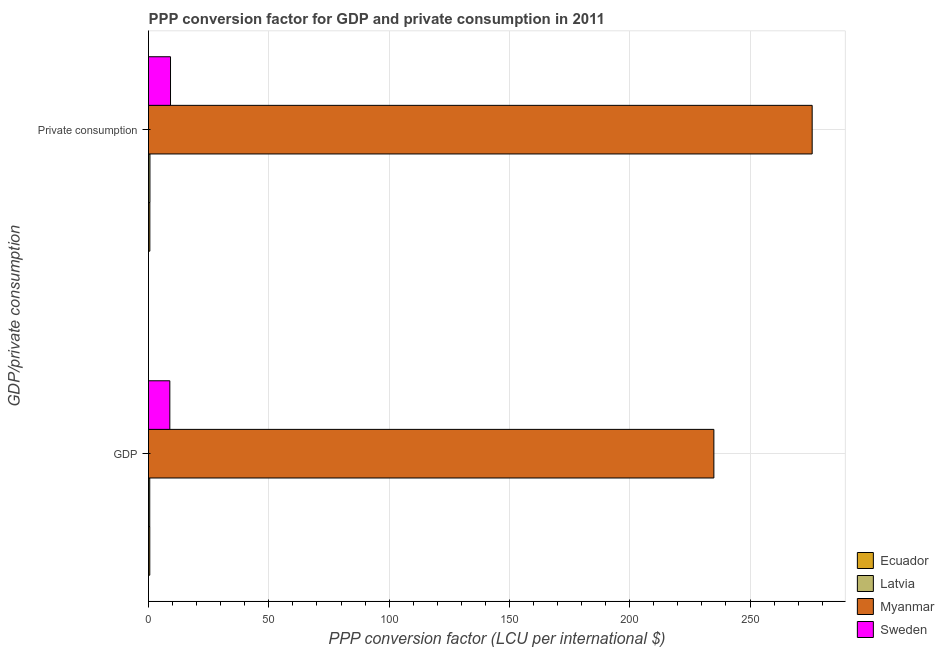How many different coloured bars are there?
Ensure brevity in your answer.  4. Are the number of bars on each tick of the Y-axis equal?
Provide a short and direct response. Yes. What is the label of the 1st group of bars from the top?
Ensure brevity in your answer.   Private consumption. What is the ppp conversion factor for private consumption in Myanmar?
Offer a terse response. 275.83. Across all countries, what is the maximum ppp conversion factor for gdp?
Your answer should be very brief. 234.97. Across all countries, what is the minimum ppp conversion factor for gdp?
Offer a terse response. 0.51. In which country was the ppp conversion factor for private consumption maximum?
Your answer should be compact. Myanmar. In which country was the ppp conversion factor for private consumption minimum?
Your answer should be compact. Ecuador. What is the total ppp conversion factor for private consumption in the graph?
Offer a terse response. 286.1. What is the difference between the ppp conversion factor for gdp in Sweden and that in Myanmar?
Offer a terse response. -226.12. What is the difference between the ppp conversion factor for private consumption in Sweden and the ppp conversion factor for gdp in Latvia?
Keep it short and to the point. 8.63. What is the average ppp conversion factor for gdp per country?
Your response must be concise. 61.21. What is the difference between the ppp conversion factor for private consumption and ppp conversion factor for gdp in Ecuador?
Your answer should be very brief. 0.02. What is the ratio of the ppp conversion factor for private consumption in Latvia to that in Myanmar?
Keep it short and to the point. 0. Is the ppp conversion factor for gdp in Sweden less than that in Latvia?
Provide a succinct answer. No. In how many countries, is the ppp conversion factor for gdp greater than the average ppp conversion factor for gdp taken over all countries?
Ensure brevity in your answer.  1. What does the 4th bar from the top in  Private consumption represents?
Your answer should be compact. Ecuador. What does the 4th bar from the bottom in  Private consumption represents?
Make the answer very short. Sweden. How many bars are there?
Provide a succinct answer. 8. Are all the bars in the graph horizontal?
Provide a succinct answer. Yes. Does the graph contain any zero values?
Keep it short and to the point. No. Where does the legend appear in the graph?
Make the answer very short. Bottom right. What is the title of the graph?
Your response must be concise. PPP conversion factor for GDP and private consumption in 2011. Does "Germany" appear as one of the legend labels in the graph?
Your answer should be very brief. No. What is the label or title of the X-axis?
Your answer should be compact. PPP conversion factor (LCU per international $). What is the label or title of the Y-axis?
Offer a terse response. GDP/private consumption. What is the PPP conversion factor (LCU per international $) of Ecuador in GDP?
Offer a terse response. 0.53. What is the PPP conversion factor (LCU per international $) of Latvia in GDP?
Your answer should be very brief. 0.51. What is the PPP conversion factor (LCU per international $) of Myanmar in GDP?
Your answer should be very brief. 234.97. What is the PPP conversion factor (LCU per international $) in Sweden in GDP?
Keep it short and to the point. 8.85. What is the PPP conversion factor (LCU per international $) in Ecuador in  Private consumption?
Give a very brief answer. 0.55. What is the PPP conversion factor (LCU per international $) of Latvia in  Private consumption?
Provide a short and direct response. 0.59. What is the PPP conversion factor (LCU per international $) in Myanmar in  Private consumption?
Offer a terse response. 275.83. What is the PPP conversion factor (LCU per international $) of Sweden in  Private consumption?
Offer a very short reply. 9.14. Across all GDP/private consumption, what is the maximum PPP conversion factor (LCU per international $) in Ecuador?
Offer a terse response. 0.55. Across all GDP/private consumption, what is the maximum PPP conversion factor (LCU per international $) in Latvia?
Your response must be concise. 0.59. Across all GDP/private consumption, what is the maximum PPP conversion factor (LCU per international $) of Myanmar?
Provide a succinct answer. 275.83. Across all GDP/private consumption, what is the maximum PPP conversion factor (LCU per international $) of Sweden?
Keep it short and to the point. 9.14. Across all GDP/private consumption, what is the minimum PPP conversion factor (LCU per international $) of Ecuador?
Your response must be concise. 0.53. Across all GDP/private consumption, what is the minimum PPP conversion factor (LCU per international $) of Latvia?
Offer a terse response. 0.51. Across all GDP/private consumption, what is the minimum PPP conversion factor (LCU per international $) in Myanmar?
Provide a short and direct response. 234.97. Across all GDP/private consumption, what is the minimum PPP conversion factor (LCU per international $) in Sweden?
Your response must be concise. 8.85. What is the total PPP conversion factor (LCU per international $) in Ecuador in the graph?
Make the answer very short. 1.07. What is the total PPP conversion factor (LCU per international $) of Latvia in the graph?
Make the answer very short. 1.09. What is the total PPP conversion factor (LCU per international $) in Myanmar in the graph?
Your answer should be compact. 510.8. What is the total PPP conversion factor (LCU per international $) of Sweden in the graph?
Give a very brief answer. 17.99. What is the difference between the PPP conversion factor (LCU per international $) of Ecuador in GDP and that in  Private consumption?
Your response must be concise. -0.02. What is the difference between the PPP conversion factor (LCU per international $) in Latvia in GDP and that in  Private consumption?
Keep it short and to the point. -0.08. What is the difference between the PPP conversion factor (LCU per international $) of Myanmar in GDP and that in  Private consumption?
Provide a succinct answer. -40.85. What is the difference between the PPP conversion factor (LCU per international $) in Sweden in GDP and that in  Private consumption?
Provide a short and direct response. -0.29. What is the difference between the PPP conversion factor (LCU per international $) in Ecuador in GDP and the PPP conversion factor (LCU per international $) in Latvia in  Private consumption?
Offer a very short reply. -0.06. What is the difference between the PPP conversion factor (LCU per international $) of Ecuador in GDP and the PPP conversion factor (LCU per international $) of Myanmar in  Private consumption?
Your response must be concise. -275.3. What is the difference between the PPP conversion factor (LCU per international $) in Ecuador in GDP and the PPP conversion factor (LCU per international $) in Sweden in  Private consumption?
Give a very brief answer. -8.61. What is the difference between the PPP conversion factor (LCU per international $) in Latvia in GDP and the PPP conversion factor (LCU per international $) in Myanmar in  Private consumption?
Keep it short and to the point. -275.32. What is the difference between the PPP conversion factor (LCU per international $) of Latvia in GDP and the PPP conversion factor (LCU per international $) of Sweden in  Private consumption?
Your answer should be compact. -8.63. What is the difference between the PPP conversion factor (LCU per international $) in Myanmar in GDP and the PPP conversion factor (LCU per international $) in Sweden in  Private consumption?
Provide a succinct answer. 225.84. What is the average PPP conversion factor (LCU per international $) of Ecuador per GDP/private consumption?
Offer a terse response. 0.54. What is the average PPP conversion factor (LCU per international $) of Latvia per GDP/private consumption?
Provide a short and direct response. 0.55. What is the average PPP conversion factor (LCU per international $) in Myanmar per GDP/private consumption?
Provide a succinct answer. 255.4. What is the average PPP conversion factor (LCU per international $) of Sweden per GDP/private consumption?
Your response must be concise. 9. What is the difference between the PPP conversion factor (LCU per international $) in Ecuador and PPP conversion factor (LCU per international $) in Latvia in GDP?
Ensure brevity in your answer.  0.02. What is the difference between the PPP conversion factor (LCU per international $) of Ecuador and PPP conversion factor (LCU per international $) of Myanmar in GDP?
Give a very brief answer. -234.45. What is the difference between the PPP conversion factor (LCU per international $) of Ecuador and PPP conversion factor (LCU per international $) of Sweden in GDP?
Provide a succinct answer. -8.33. What is the difference between the PPP conversion factor (LCU per international $) in Latvia and PPP conversion factor (LCU per international $) in Myanmar in GDP?
Provide a short and direct response. -234.47. What is the difference between the PPP conversion factor (LCU per international $) in Latvia and PPP conversion factor (LCU per international $) in Sweden in GDP?
Your answer should be compact. -8.35. What is the difference between the PPP conversion factor (LCU per international $) in Myanmar and PPP conversion factor (LCU per international $) in Sweden in GDP?
Ensure brevity in your answer.  226.12. What is the difference between the PPP conversion factor (LCU per international $) in Ecuador and PPP conversion factor (LCU per international $) in Latvia in  Private consumption?
Give a very brief answer. -0.04. What is the difference between the PPP conversion factor (LCU per international $) of Ecuador and PPP conversion factor (LCU per international $) of Myanmar in  Private consumption?
Your response must be concise. -275.28. What is the difference between the PPP conversion factor (LCU per international $) of Ecuador and PPP conversion factor (LCU per international $) of Sweden in  Private consumption?
Give a very brief answer. -8.59. What is the difference between the PPP conversion factor (LCU per international $) in Latvia and PPP conversion factor (LCU per international $) in Myanmar in  Private consumption?
Your response must be concise. -275.24. What is the difference between the PPP conversion factor (LCU per international $) in Latvia and PPP conversion factor (LCU per international $) in Sweden in  Private consumption?
Offer a very short reply. -8.55. What is the difference between the PPP conversion factor (LCU per international $) of Myanmar and PPP conversion factor (LCU per international $) of Sweden in  Private consumption?
Your answer should be compact. 266.69. What is the ratio of the PPP conversion factor (LCU per international $) of Ecuador in GDP to that in  Private consumption?
Make the answer very short. 0.96. What is the ratio of the PPP conversion factor (LCU per international $) in Latvia in GDP to that in  Private consumption?
Make the answer very short. 0.86. What is the ratio of the PPP conversion factor (LCU per international $) of Myanmar in GDP to that in  Private consumption?
Offer a terse response. 0.85. What is the ratio of the PPP conversion factor (LCU per international $) of Sweden in GDP to that in  Private consumption?
Keep it short and to the point. 0.97. What is the difference between the highest and the second highest PPP conversion factor (LCU per international $) in Ecuador?
Your answer should be very brief. 0.02. What is the difference between the highest and the second highest PPP conversion factor (LCU per international $) in Latvia?
Offer a very short reply. 0.08. What is the difference between the highest and the second highest PPP conversion factor (LCU per international $) in Myanmar?
Keep it short and to the point. 40.85. What is the difference between the highest and the second highest PPP conversion factor (LCU per international $) in Sweden?
Your response must be concise. 0.29. What is the difference between the highest and the lowest PPP conversion factor (LCU per international $) of Ecuador?
Ensure brevity in your answer.  0.02. What is the difference between the highest and the lowest PPP conversion factor (LCU per international $) of Latvia?
Provide a succinct answer. 0.08. What is the difference between the highest and the lowest PPP conversion factor (LCU per international $) in Myanmar?
Give a very brief answer. 40.85. What is the difference between the highest and the lowest PPP conversion factor (LCU per international $) in Sweden?
Your answer should be very brief. 0.29. 